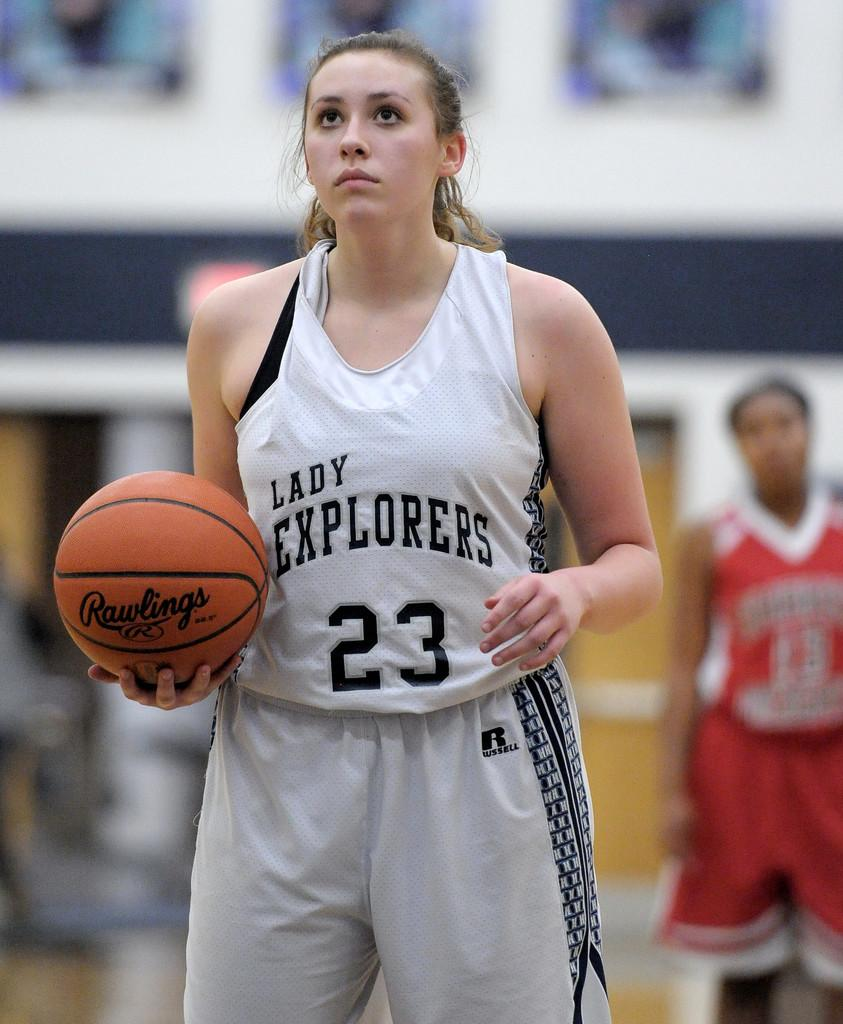<image>
Relay a brief, clear account of the picture shown. A woman holding a basketball wears a basketball jersey saying Lady Explorers. 